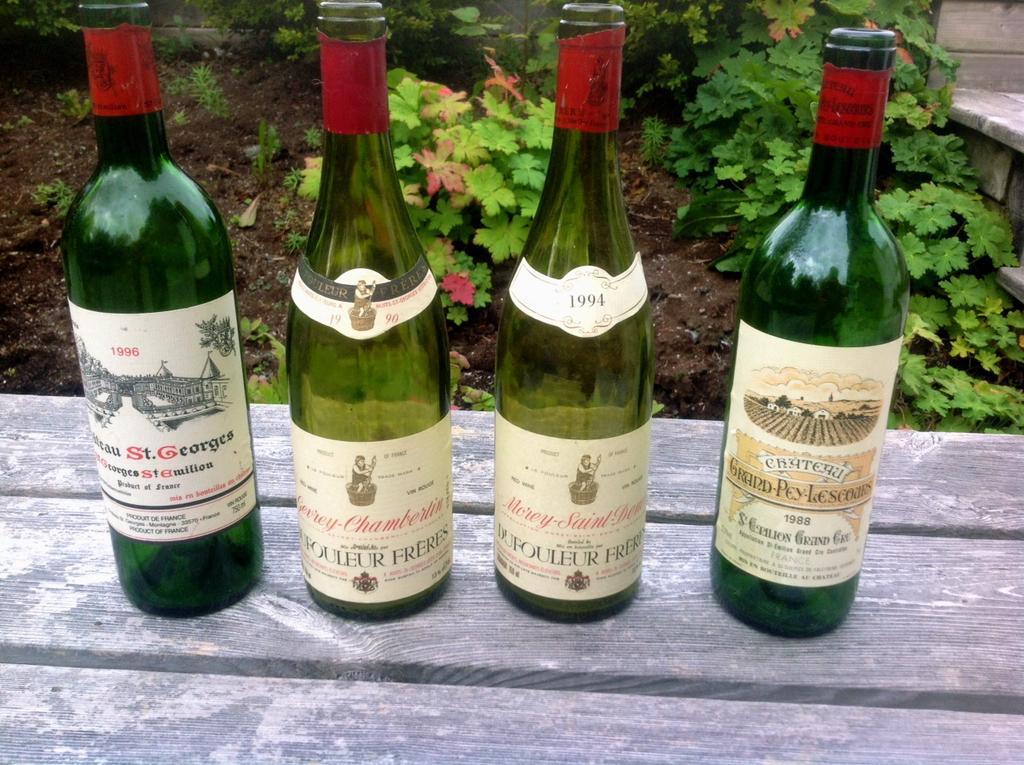In one or two sentences, can you explain what this image depicts? This is a picture taken in the outdoors. On the bench there are four wine bottles. The bottles are in green color. Behind the bottle there are plants and soil. 